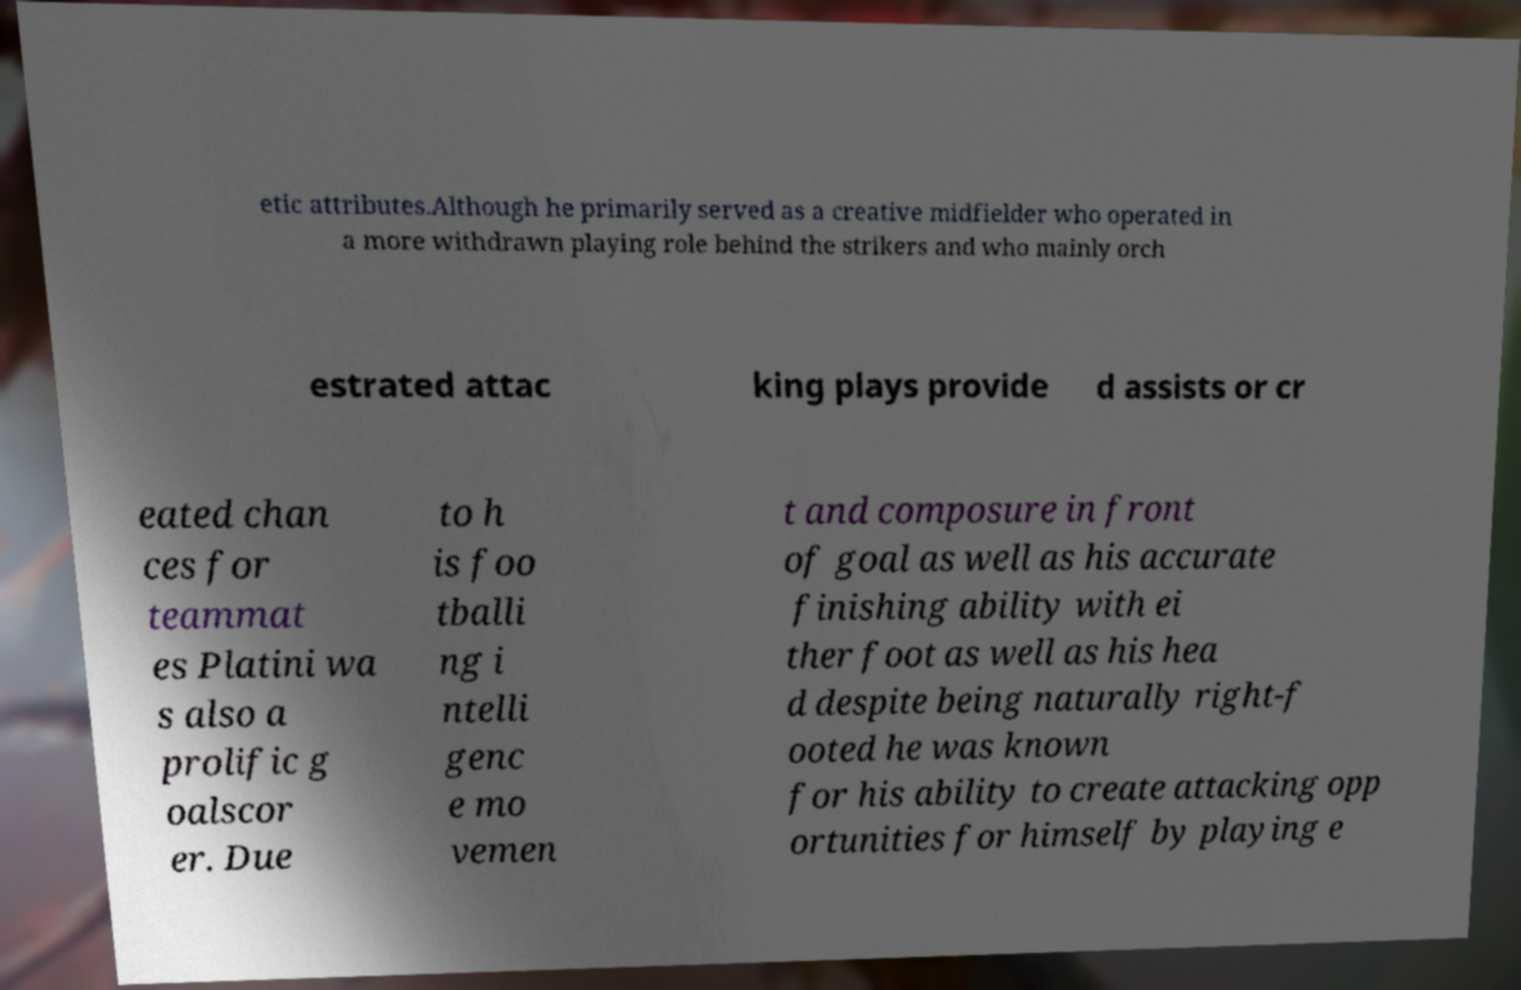Please identify and transcribe the text found in this image. etic attributes.Although he primarily served as a creative midfielder who operated in a more withdrawn playing role behind the strikers and who mainly orch estrated attac king plays provide d assists or cr eated chan ces for teammat es Platini wa s also a prolific g oalscor er. Due to h is foo tballi ng i ntelli genc e mo vemen t and composure in front of goal as well as his accurate finishing ability with ei ther foot as well as his hea d despite being naturally right-f ooted he was known for his ability to create attacking opp ortunities for himself by playing e 